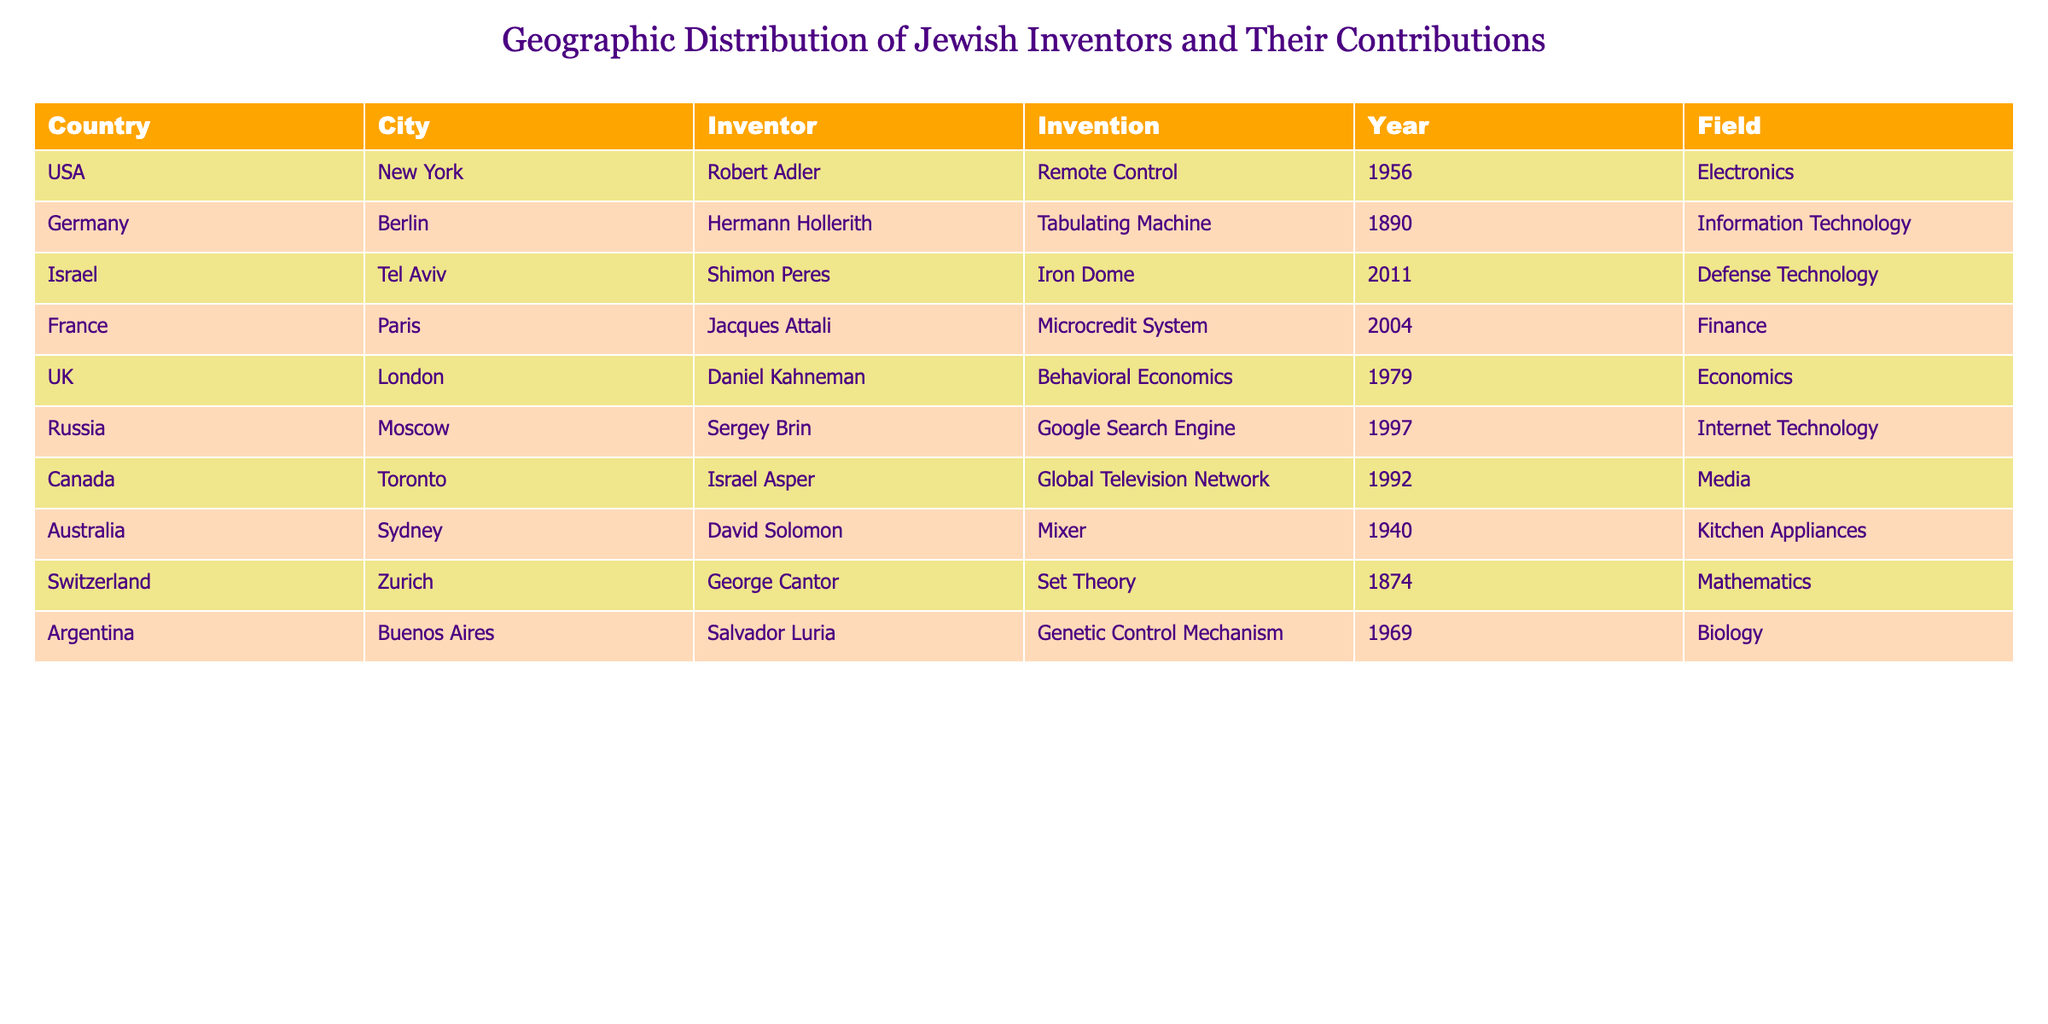What invention did Robert Adler create? According to the table, Robert Adler is listed under the USA in New York and is noted for inventing the remote control in 1956.
Answer: Remote Control Which country is associated with Hermann Hollerith? The table indicates that Hermann Hollerith, inventor of the tabulating machine, is from Germany, specifically Berlin.
Answer: Germany How many inventors contributed to the field of Economics? In the table, only Daniel Kahneman is identified in the field of Economics, and he is listed next to the UK and London as the location. Therefore, there is one inventor in this field.
Answer: 1 Did any inventor create an invention in the field of Defense Technology before the year 2000? The table shows that Shimon Peres created the Iron Dome in 2011, which is after the year 2000, meaning there were no contributions in this field before 2000 based on the available data.
Answer: No Which city produced the earliest invention according to the table? The table lists George Cantor’s invention, set theory, from 1874 in Zurich, Switzerland, making it the earliest among the inventions provided. To confirm, I compare the years of all the listed inventions.
Answer: Zurich How many years apart were the inventions of the Remote Control and the Iron Dome? The Remote Control was invented in 1956 and the Iron Dome in 2011. To find the difference, I subtract 1956 from 2011, which equals 55 years.
Answer: 55 years Is it true that all the inventors listed are from European countries? The table includes inventors from countries like the USA and Israel, which are not European. Based on this, the statement is false.
Answer: No What is the total number of inventions listed in the table? Counting each entry in the table, there are ten unique inventions listed, correlating with the ten inventors presented.
Answer: 10 Which field has the most diverse geographical representation among the inventors, according to the table? By examining the table, fields such as Electronics, Information Technology, and Biology each have inventors from different countries. However, "Media" with an inventor from Canada and the "Defense Technology" with a contributor from Israel shows diversity. Thus, various fields have global input. This reflects a moderate diversity of geography in various fields, but I need to conclude with a specific field.
Answer: Media (Canada) How many inventors contributed to the field of Biology? The table shows that only Salvador Luria is listed under the field of Biology, contributing with the genetic control mechanism in Argentina in 1969. Thus, there is one inventor in this category.
Answer: 1 